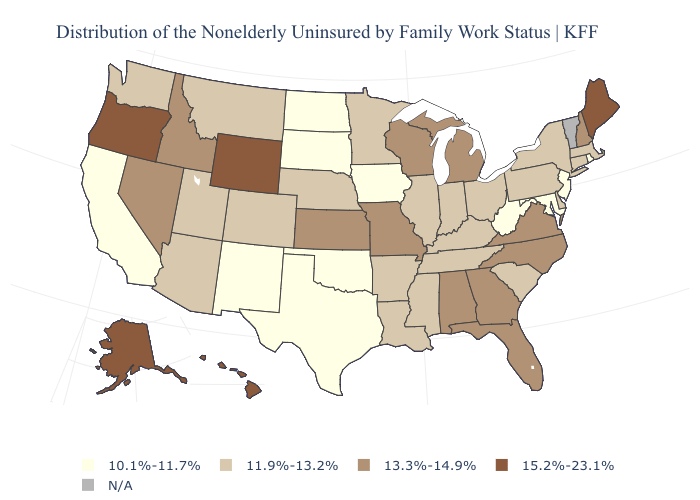Does Hawaii have the highest value in the USA?
Quick response, please. Yes. Name the states that have a value in the range N/A?
Quick response, please. Vermont. What is the value of Alabama?
Answer briefly. 13.3%-14.9%. What is the value of Oregon?
Quick response, please. 15.2%-23.1%. Does the map have missing data?
Be succinct. Yes. Name the states that have a value in the range 10.1%-11.7%?
Be succinct. California, Iowa, Maryland, New Jersey, New Mexico, North Dakota, Oklahoma, Rhode Island, South Dakota, Texas, West Virginia. Does Rhode Island have the highest value in the Northeast?
Short answer required. No. Does the first symbol in the legend represent the smallest category?
Quick response, please. Yes. What is the value of Montana?
Quick response, please. 11.9%-13.2%. What is the highest value in the Northeast ?
Quick response, please. 15.2%-23.1%. What is the lowest value in states that border Oklahoma?
Quick response, please. 10.1%-11.7%. Name the states that have a value in the range 15.2%-23.1%?
Give a very brief answer. Alaska, Hawaii, Maine, Oregon, Wyoming. Name the states that have a value in the range 11.9%-13.2%?
Short answer required. Arizona, Arkansas, Colorado, Connecticut, Delaware, Illinois, Indiana, Kentucky, Louisiana, Massachusetts, Minnesota, Mississippi, Montana, Nebraska, New York, Ohio, Pennsylvania, South Carolina, Tennessee, Utah, Washington. 